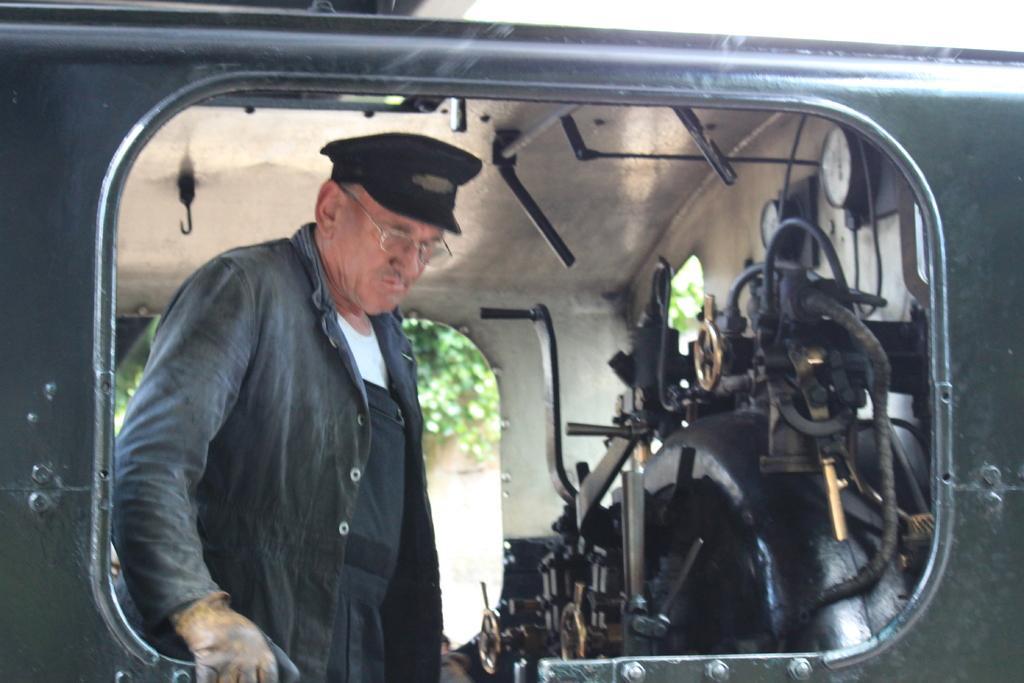Could you give a brief overview of what you see in this image? This picture is an inside view of a train. On the left side of the image we can see a man is standing and wearing glove, spectacles, hat. On the right side of the image we can see a machine. In the background of the image we can see trees, roof, clock. 